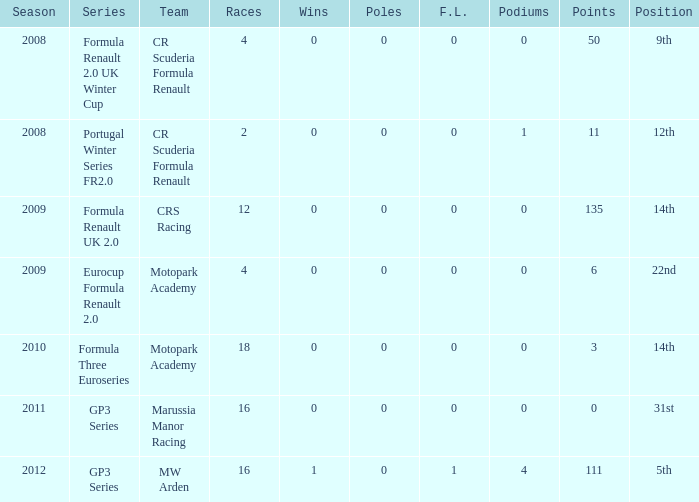How many points does Marussia Manor Racing have? 1.0. Write the full table. {'header': ['Season', 'Series', 'Team', 'Races', 'Wins', 'Poles', 'F.L.', 'Podiums', 'Points', 'Position'], 'rows': [['2008', 'Formula Renault 2.0 UK Winter Cup', 'CR Scuderia Formula Renault', '4', '0', '0', '0', '0', '50', '9th'], ['2008', 'Portugal Winter Series FR2.0', 'CR Scuderia Formula Renault', '2', '0', '0', '0', '1', '11', '12th'], ['2009', 'Formula Renault UK 2.0', 'CRS Racing', '12', '0', '0', '0', '0', '135', '14th'], ['2009', 'Eurocup Formula Renault 2.0', 'Motopark Academy', '4', '0', '0', '0', '0', '6', '22nd'], ['2010', 'Formula Three Euroseries', 'Motopark Academy', '18', '0', '0', '0', '0', '3', '14th'], ['2011', 'GP3 Series', 'Marussia Manor Racing', '16', '0', '0', '0', '0', '0', '31st'], ['2012', 'GP3 Series', 'MW Arden', '16', '1', '0', '1', '4', '111', '5th']]} 